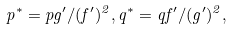Convert formula to latex. <formula><loc_0><loc_0><loc_500><loc_500>p ^ { * } = p g ^ { \prime } / ( f ^ { \prime } ) ^ { 2 } , q ^ { * } = q f ^ { \prime } / ( g ^ { \prime } ) ^ { 2 } ,</formula> 